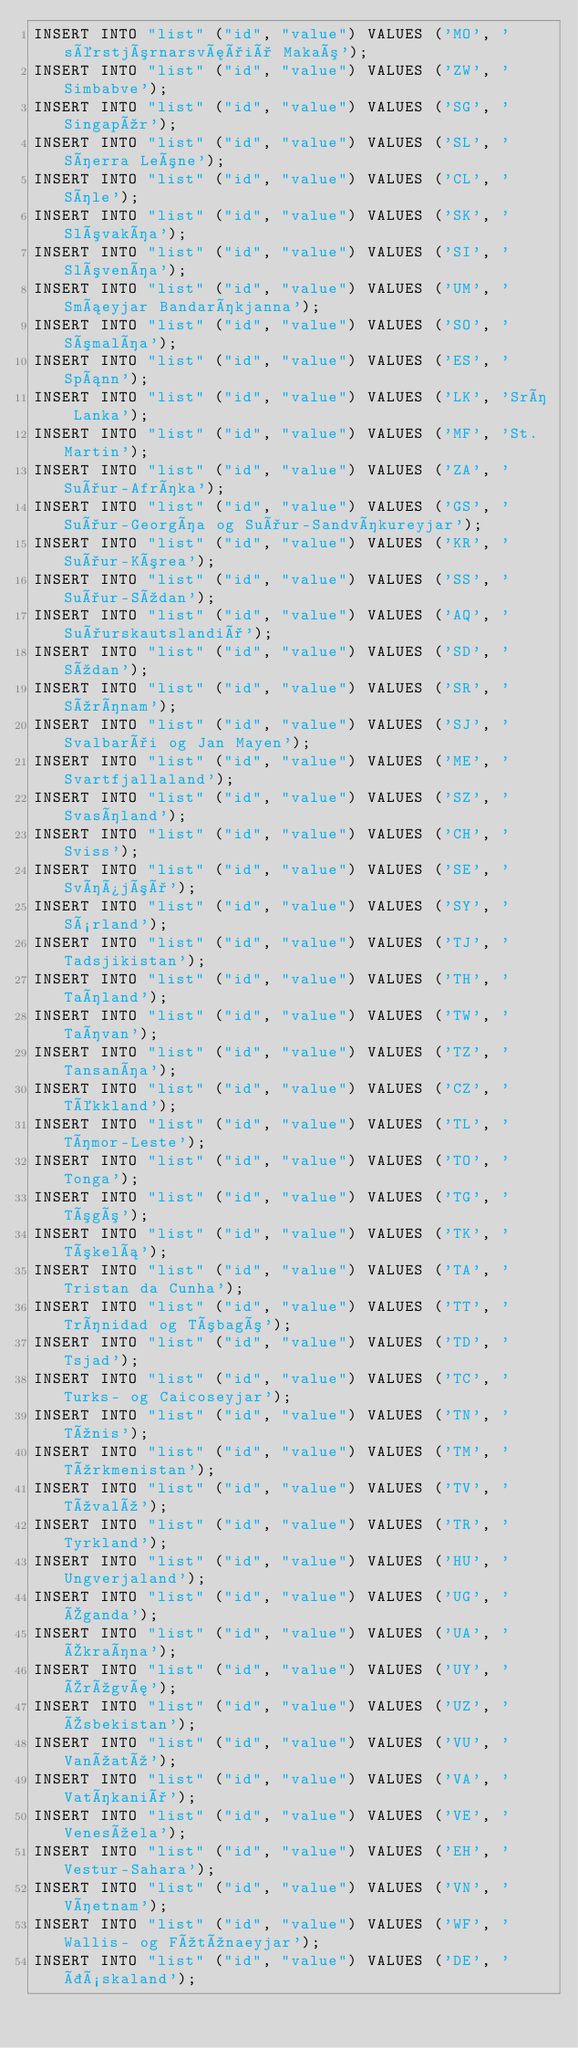<code> <loc_0><loc_0><loc_500><loc_500><_SQL_>INSERT INTO "list" ("id", "value") VALUES ('MO', 'sérstjórnarsvæðið Makaó');
INSERT INTO "list" ("id", "value") VALUES ('ZW', 'Simbabve');
INSERT INTO "list" ("id", "value") VALUES ('SG', 'Singapúr');
INSERT INTO "list" ("id", "value") VALUES ('SL', 'Síerra Leóne');
INSERT INTO "list" ("id", "value") VALUES ('CL', 'Síle');
INSERT INTO "list" ("id", "value") VALUES ('SK', 'Slóvakía');
INSERT INTO "list" ("id", "value") VALUES ('SI', 'Slóvenía');
INSERT INTO "list" ("id", "value") VALUES ('UM', 'Smáeyjar Bandaríkjanna');
INSERT INTO "list" ("id", "value") VALUES ('SO', 'Sómalía');
INSERT INTO "list" ("id", "value") VALUES ('ES', 'Spánn');
INSERT INTO "list" ("id", "value") VALUES ('LK', 'Srí Lanka');
INSERT INTO "list" ("id", "value") VALUES ('MF', 'St. Martin');
INSERT INTO "list" ("id", "value") VALUES ('ZA', 'Suður-Afríka');
INSERT INTO "list" ("id", "value") VALUES ('GS', 'Suður-Georgía og Suður-Sandvíkureyjar');
INSERT INTO "list" ("id", "value") VALUES ('KR', 'Suður-Kórea');
INSERT INTO "list" ("id", "value") VALUES ('SS', 'Suður-Súdan');
INSERT INTO "list" ("id", "value") VALUES ('AQ', 'Suðurskautslandið');
INSERT INTO "list" ("id", "value") VALUES ('SD', 'Súdan');
INSERT INTO "list" ("id", "value") VALUES ('SR', 'Súrínam');
INSERT INTO "list" ("id", "value") VALUES ('SJ', 'Svalbarði og Jan Mayen');
INSERT INTO "list" ("id", "value") VALUES ('ME', 'Svartfjallaland');
INSERT INTO "list" ("id", "value") VALUES ('SZ', 'Svasíland');
INSERT INTO "list" ("id", "value") VALUES ('CH', 'Sviss');
INSERT INTO "list" ("id", "value") VALUES ('SE', 'Svíþjóð');
INSERT INTO "list" ("id", "value") VALUES ('SY', 'Sýrland');
INSERT INTO "list" ("id", "value") VALUES ('TJ', 'Tadsjikistan');
INSERT INTO "list" ("id", "value") VALUES ('TH', 'Taíland');
INSERT INTO "list" ("id", "value") VALUES ('TW', 'Taívan');
INSERT INTO "list" ("id", "value") VALUES ('TZ', 'Tansanía');
INSERT INTO "list" ("id", "value") VALUES ('CZ', 'Tékkland');
INSERT INTO "list" ("id", "value") VALUES ('TL', 'Tímor-Leste');
INSERT INTO "list" ("id", "value") VALUES ('TO', 'Tonga');
INSERT INTO "list" ("id", "value") VALUES ('TG', 'Tógó');
INSERT INTO "list" ("id", "value") VALUES ('TK', 'Tókelá');
INSERT INTO "list" ("id", "value") VALUES ('TA', 'Tristan da Cunha');
INSERT INTO "list" ("id", "value") VALUES ('TT', 'Trínidad og Tóbagó');
INSERT INTO "list" ("id", "value") VALUES ('TD', 'Tsjad');
INSERT INTO "list" ("id", "value") VALUES ('TC', 'Turks- og Caicoseyjar');
INSERT INTO "list" ("id", "value") VALUES ('TN', 'Túnis');
INSERT INTO "list" ("id", "value") VALUES ('TM', 'Túrkmenistan');
INSERT INTO "list" ("id", "value") VALUES ('TV', 'Túvalú');
INSERT INTO "list" ("id", "value") VALUES ('TR', 'Tyrkland');
INSERT INTO "list" ("id", "value") VALUES ('HU', 'Ungverjaland');
INSERT INTO "list" ("id", "value") VALUES ('UG', 'Úganda');
INSERT INTO "list" ("id", "value") VALUES ('UA', 'Úkraína');
INSERT INTO "list" ("id", "value") VALUES ('UY', 'Úrúgvæ');
INSERT INTO "list" ("id", "value") VALUES ('UZ', 'Úsbekistan');
INSERT INTO "list" ("id", "value") VALUES ('VU', 'Vanúatú');
INSERT INTO "list" ("id", "value") VALUES ('VA', 'Vatíkanið');
INSERT INTO "list" ("id", "value") VALUES ('VE', 'Venesúela');
INSERT INTO "list" ("id", "value") VALUES ('EH', 'Vestur-Sahara');
INSERT INTO "list" ("id", "value") VALUES ('VN', 'Víetnam');
INSERT INTO "list" ("id", "value") VALUES ('WF', 'Wallis- og Fútúnaeyjar');
INSERT INTO "list" ("id", "value") VALUES ('DE', 'Þýskaland');
</code> 